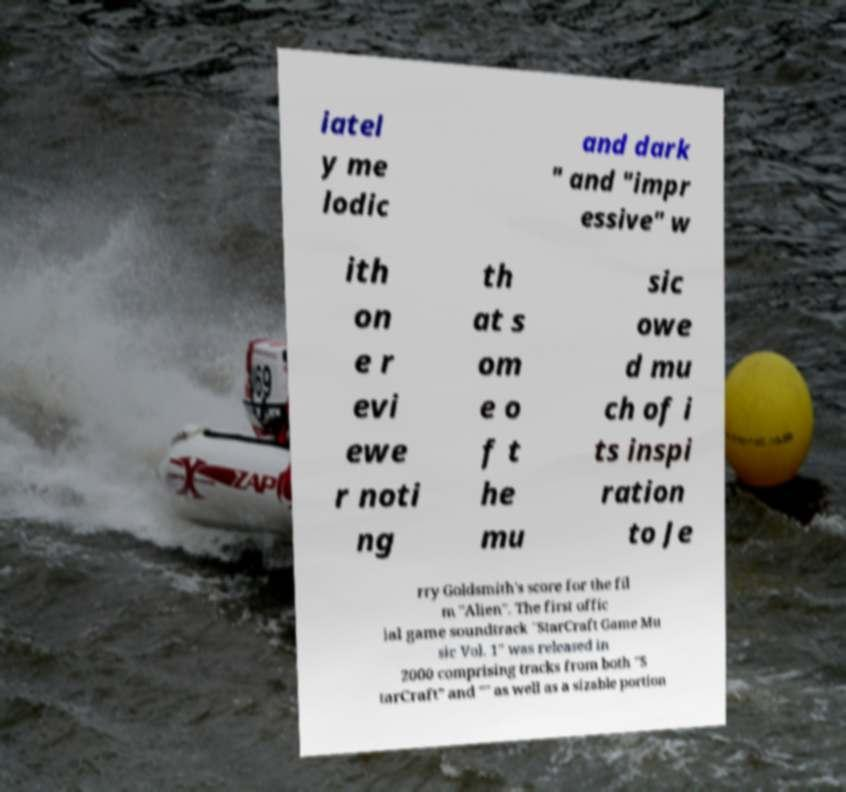For documentation purposes, I need the text within this image transcribed. Could you provide that? iatel y me lodic and dark " and "impr essive" w ith on e r evi ewe r noti ng th at s om e o f t he mu sic owe d mu ch of i ts inspi ration to Je rry Goldsmith's score for the fil m "Alien". The first offic ial game soundtrack "StarCraft Game Mu sic Vol. 1" was released in 2000 comprising tracks from both "S tarCraft" and "" as well as a sizable portion 